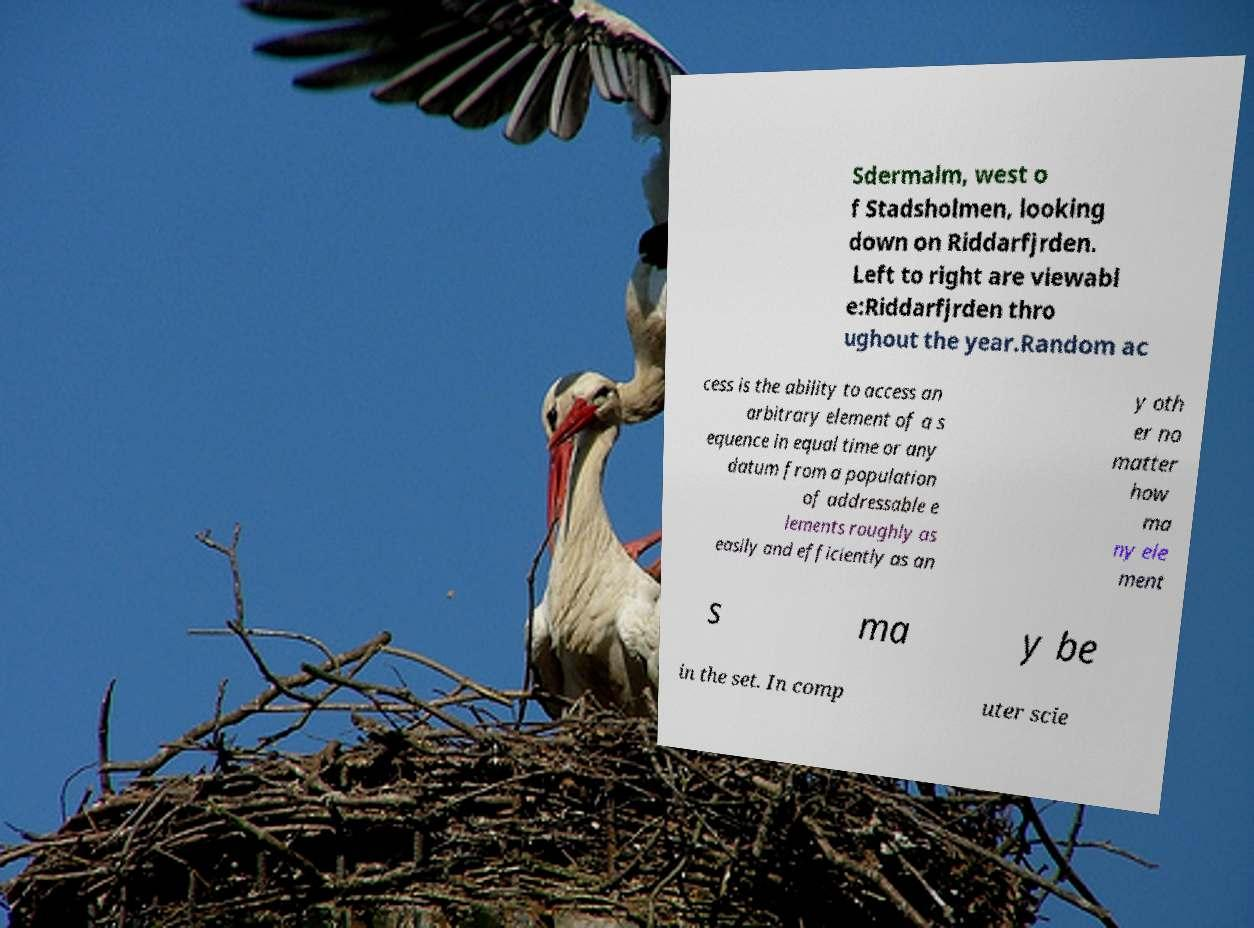Could you extract and type out the text from this image? Sdermalm, west o f Stadsholmen, looking down on Riddarfjrden. Left to right are viewabl e:Riddarfjrden thro ughout the year.Random ac cess is the ability to access an arbitrary element of a s equence in equal time or any datum from a population of addressable e lements roughly as easily and efficiently as an y oth er no matter how ma ny ele ment s ma y be in the set. In comp uter scie 